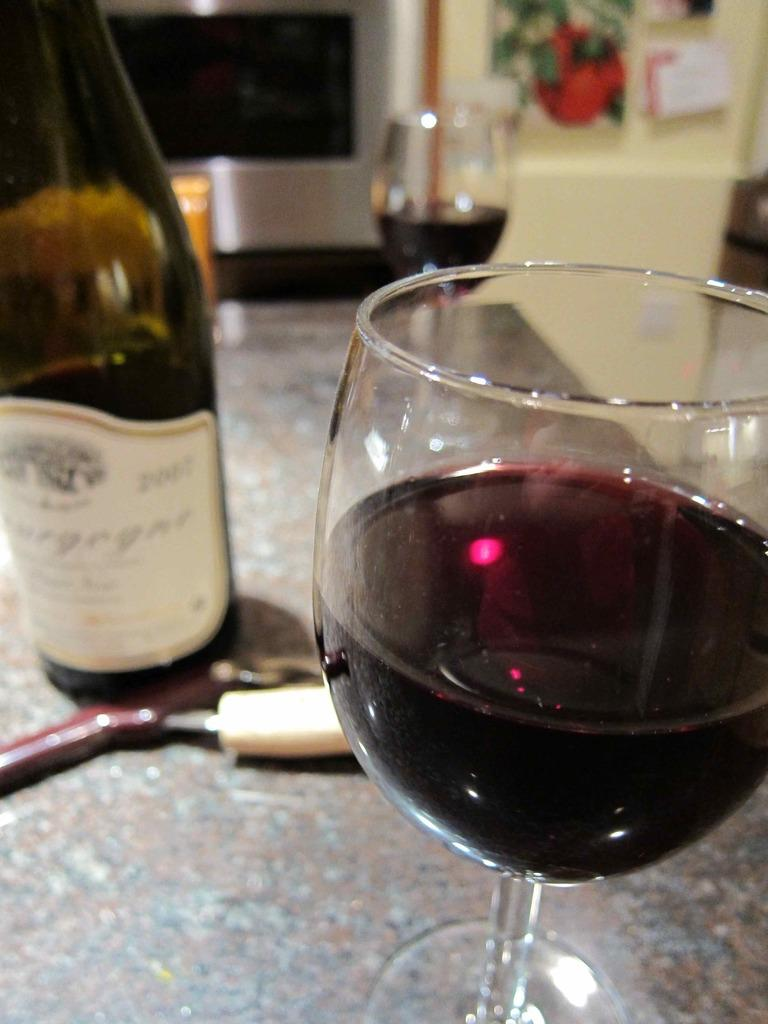What can be seen in the image that is used for holding liquids? There is a bottle and two glasses in the image. What is inside the glasses? The glasses contain wine. What is on the bottle that provides information about its contents? There is a label on the bottle. What architectural feature can be seen in the background of the image? There is a door in the background of the image. How is the door depicted in the image? The door is blurred. Can you see any hens in the image? There are no hens present in the image. What is the elbow used for in the image? There is no elbow depicted in the image. 